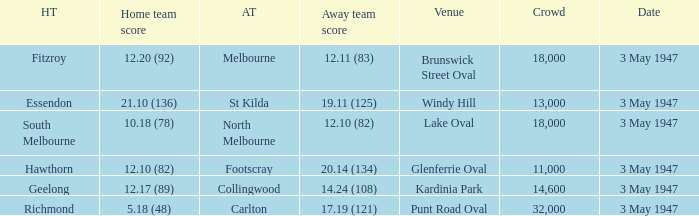In the game where the away team score is 17.19 (121), who was the away team? Carlton. 